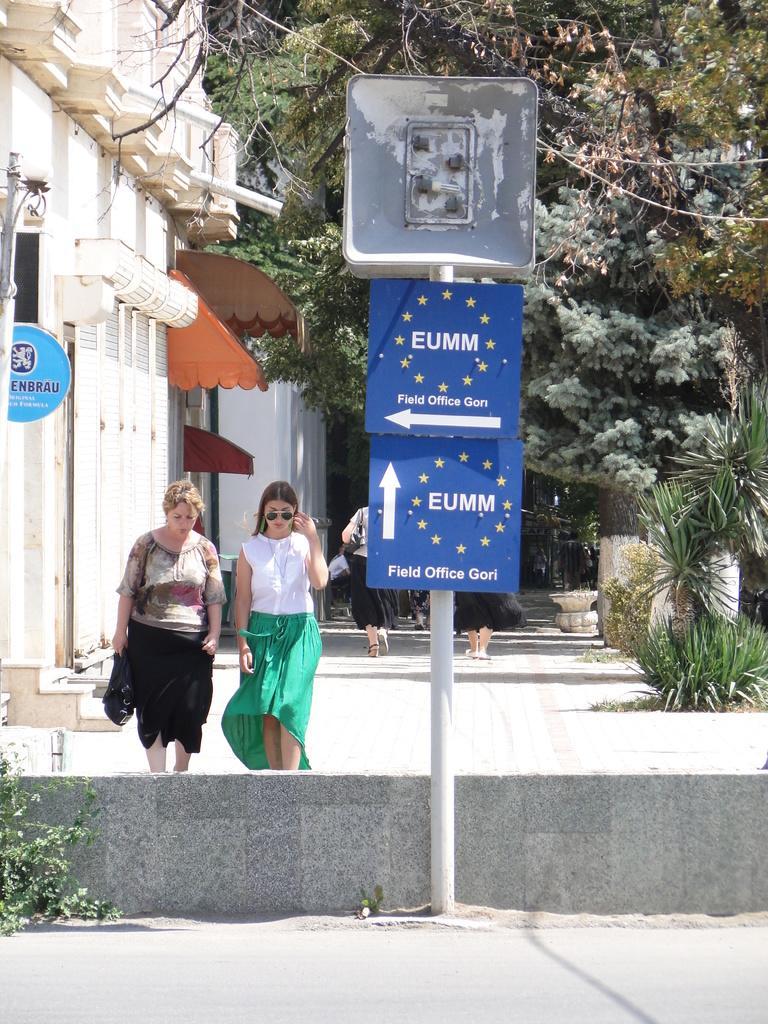Can you describe this image briefly? In the center of the image there is a sign board. There are two ladies walking. In the background of the image there are trees. There is a building. At the bottom of the image there is a road. 